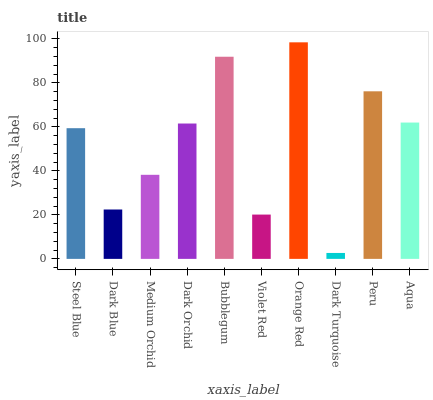Is Dark Turquoise the minimum?
Answer yes or no. Yes. Is Orange Red the maximum?
Answer yes or no. Yes. Is Dark Blue the minimum?
Answer yes or no. No. Is Dark Blue the maximum?
Answer yes or no. No. Is Steel Blue greater than Dark Blue?
Answer yes or no. Yes. Is Dark Blue less than Steel Blue?
Answer yes or no. Yes. Is Dark Blue greater than Steel Blue?
Answer yes or no. No. Is Steel Blue less than Dark Blue?
Answer yes or no. No. Is Dark Orchid the high median?
Answer yes or no. Yes. Is Steel Blue the low median?
Answer yes or no. Yes. Is Bubblegum the high median?
Answer yes or no. No. Is Peru the low median?
Answer yes or no. No. 